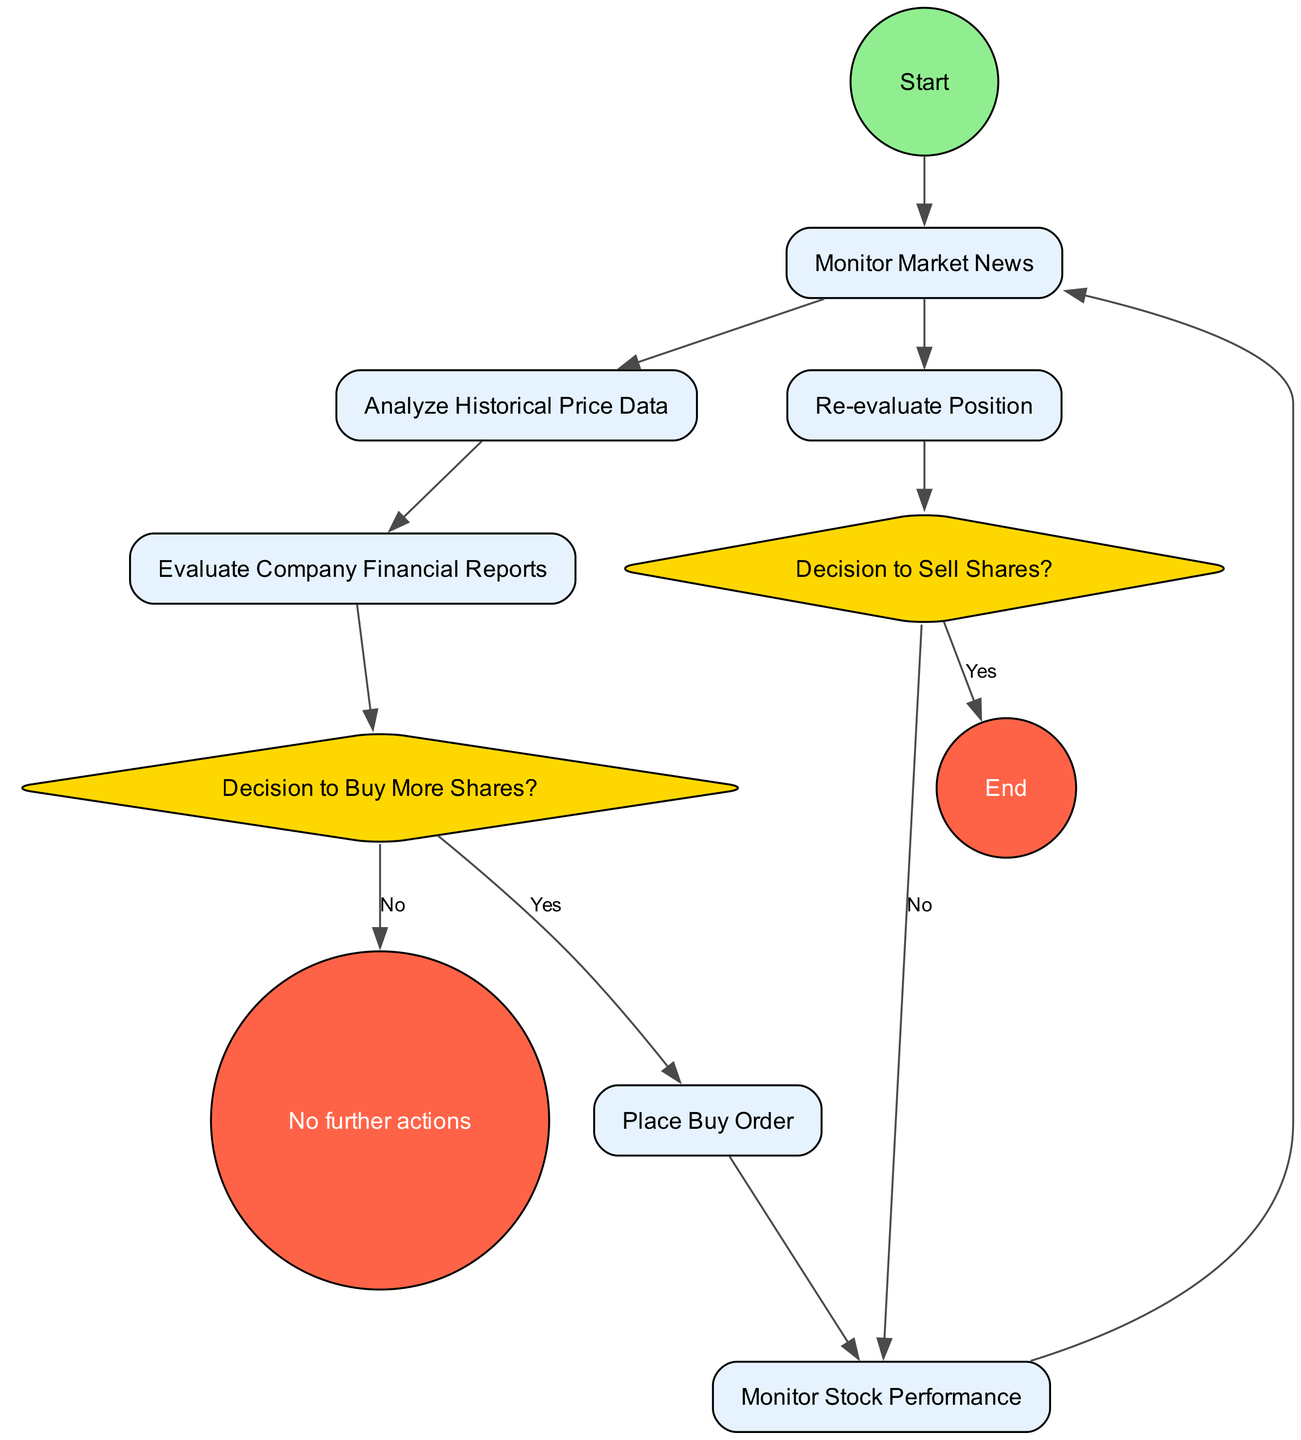What is the first activity in the decision-making process? The diagram begins with a "Start" node that leads to the first activity, which is "Monitor Market News." This is where the process initiates.
Answer: Monitor Market News How many decision nodes are present in the diagram? By analyzing the diagram, there are two decision nodes: "Decision to Buy More Shares?" and "Decision to Sell Shares?". Thus, the total count of decision nodes is two.
Answer: Two Which activity comes after placing a buy order? Following the "Place Buy Order" node, the process moves to "Monitor Stock Performance," which indicates the next step after the buy order is placed.
Answer: Monitor Stock Performance What happens if the decision to buy more shares is "No"? If the decision at the node "Decision to Buy More Shares?" is "No," the process then leads directly to "No further actions," signifying the end of that decision branch.
Answer: No further actions What is the outcome if the decision to sell shares is "Yes"? If the decision at the "Decision to Sell Shares?" node is "Yes," the process flows to the "End" node, indicating the termination of this particular flow as the shares are sold.
Answer: End What activity is monitored repeatedly during the stock performance assessment? The activity that is consistently monitored throughout the process is "Monitor Market News." It is revisited after the stock performance is assessed, indicating ongoing evaluation.
Answer: Monitor Market News How many total activities are present in the diagram? Counting all the activities listed— "Monitor Market News," "Analyze Historical Price Data," "Evaluate Company Financial Reports," "Place Buy Order," "Monitor Stock Performance," and "Re-evaluate Position" —there are six activities in total.
Answer: Six What is the last action taken before making the decision to sell shares? Before reaching the "Decision to Sell Shares?" node, the last action is "Re-evaluate Position." This indicates a reassessment of the situation just before deciding whether to sell.
Answer: Re-evaluate Position 